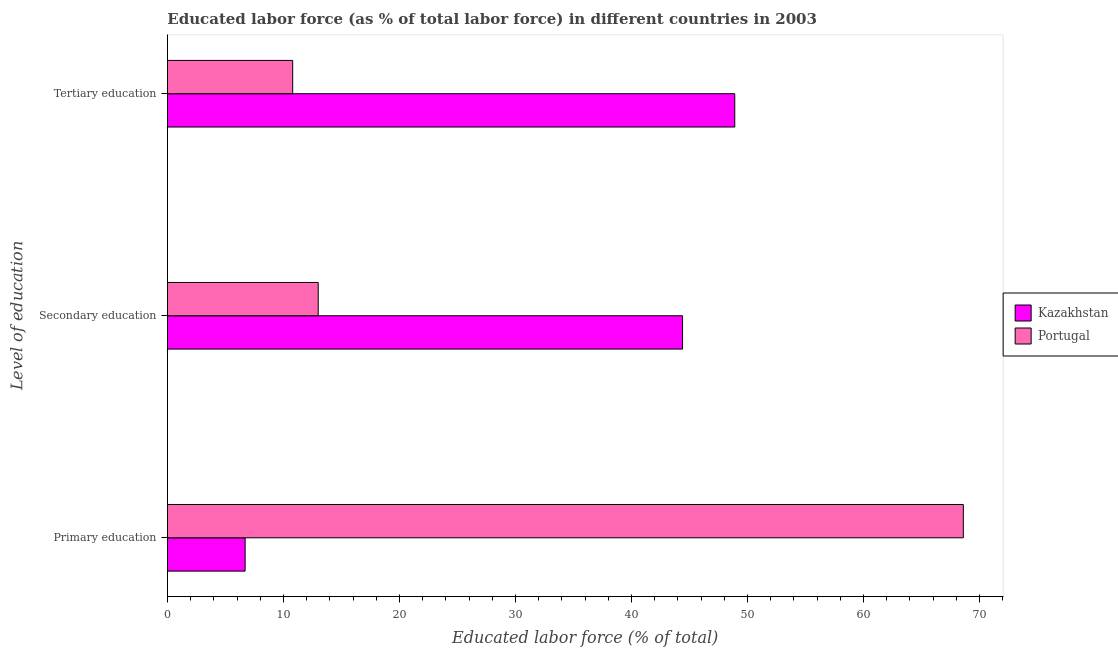How many different coloured bars are there?
Give a very brief answer. 2. How many groups of bars are there?
Provide a short and direct response. 3. Are the number of bars per tick equal to the number of legend labels?
Your answer should be compact. Yes. How many bars are there on the 2nd tick from the bottom?
Ensure brevity in your answer.  2. What is the label of the 1st group of bars from the top?
Provide a succinct answer. Tertiary education. What is the percentage of labor force who received tertiary education in Portugal?
Provide a short and direct response. 10.8. Across all countries, what is the maximum percentage of labor force who received primary education?
Offer a terse response. 68.6. In which country was the percentage of labor force who received secondary education maximum?
Offer a very short reply. Kazakhstan. In which country was the percentage of labor force who received primary education minimum?
Your answer should be compact. Kazakhstan. What is the total percentage of labor force who received secondary education in the graph?
Offer a very short reply. 57.4. What is the difference between the percentage of labor force who received secondary education in Portugal and that in Kazakhstan?
Make the answer very short. -31.4. What is the difference between the percentage of labor force who received tertiary education in Portugal and the percentage of labor force who received primary education in Kazakhstan?
Make the answer very short. 4.1. What is the average percentage of labor force who received primary education per country?
Your answer should be compact. 37.65. What is the difference between the percentage of labor force who received secondary education and percentage of labor force who received primary education in Kazakhstan?
Offer a terse response. 37.7. In how many countries, is the percentage of labor force who received primary education greater than 64 %?
Ensure brevity in your answer.  1. What is the ratio of the percentage of labor force who received tertiary education in Portugal to that in Kazakhstan?
Offer a terse response. 0.22. Is the difference between the percentage of labor force who received secondary education in Portugal and Kazakhstan greater than the difference between the percentage of labor force who received tertiary education in Portugal and Kazakhstan?
Give a very brief answer. Yes. What is the difference between the highest and the second highest percentage of labor force who received primary education?
Give a very brief answer. 61.9. What is the difference between the highest and the lowest percentage of labor force who received tertiary education?
Make the answer very short. 38.1. What does the 1st bar from the top in Primary education represents?
Provide a succinct answer. Portugal. What does the 1st bar from the bottom in Tertiary education represents?
Your answer should be very brief. Kazakhstan. Is it the case that in every country, the sum of the percentage of labor force who received primary education and percentage of labor force who received secondary education is greater than the percentage of labor force who received tertiary education?
Provide a succinct answer. Yes. How many bars are there?
Keep it short and to the point. 6. How many countries are there in the graph?
Provide a short and direct response. 2. Where does the legend appear in the graph?
Your answer should be compact. Center right. How are the legend labels stacked?
Offer a very short reply. Vertical. What is the title of the graph?
Provide a short and direct response. Educated labor force (as % of total labor force) in different countries in 2003. What is the label or title of the X-axis?
Your answer should be very brief. Educated labor force (% of total). What is the label or title of the Y-axis?
Ensure brevity in your answer.  Level of education. What is the Educated labor force (% of total) in Kazakhstan in Primary education?
Your answer should be very brief. 6.7. What is the Educated labor force (% of total) of Portugal in Primary education?
Make the answer very short. 68.6. What is the Educated labor force (% of total) in Kazakhstan in Secondary education?
Give a very brief answer. 44.4. What is the Educated labor force (% of total) in Portugal in Secondary education?
Offer a very short reply. 13. What is the Educated labor force (% of total) of Kazakhstan in Tertiary education?
Give a very brief answer. 48.9. What is the Educated labor force (% of total) of Portugal in Tertiary education?
Offer a terse response. 10.8. Across all Level of education, what is the maximum Educated labor force (% of total) in Kazakhstan?
Your response must be concise. 48.9. Across all Level of education, what is the maximum Educated labor force (% of total) of Portugal?
Your answer should be very brief. 68.6. Across all Level of education, what is the minimum Educated labor force (% of total) of Kazakhstan?
Make the answer very short. 6.7. Across all Level of education, what is the minimum Educated labor force (% of total) in Portugal?
Provide a short and direct response. 10.8. What is the total Educated labor force (% of total) in Kazakhstan in the graph?
Give a very brief answer. 100. What is the total Educated labor force (% of total) in Portugal in the graph?
Give a very brief answer. 92.4. What is the difference between the Educated labor force (% of total) of Kazakhstan in Primary education and that in Secondary education?
Provide a short and direct response. -37.7. What is the difference between the Educated labor force (% of total) of Portugal in Primary education and that in Secondary education?
Offer a terse response. 55.6. What is the difference between the Educated labor force (% of total) in Kazakhstan in Primary education and that in Tertiary education?
Your response must be concise. -42.2. What is the difference between the Educated labor force (% of total) of Portugal in Primary education and that in Tertiary education?
Your response must be concise. 57.8. What is the difference between the Educated labor force (% of total) in Portugal in Secondary education and that in Tertiary education?
Provide a succinct answer. 2.2. What is the difference between the Educated labor force (% of total) of Kazakhstan in Primary education and the Educated labor force (% of total) of Portugal in Secondary education?
Your answer should be compact. -6.3. What is the difference between the Educated labor force (% of total) of Kazakhstan in Primary education and the Educated labor force (% of total) of Portugal in Tertiary education?
Offer a very short reply. -4.1. What is the difference between the Educated labor force (% of total) in Kazakhstan in Secondary education and the Educated labor force (% of total) in Portugal in Tertiary education?
Provide a short and direct response. 33.6. What is the average Educated labor force (% of total) in Kazakhstan per Level of education?
Your answer should be very brief. 33.33. What is the average Educated labor force (% of total) of Portugal per Level of education?
Your answer should be very brief. 30.8. What is the difference between the Educated labor force (% of total) in Kazakhstan and Educated labor force (% of total) in Portugal in Primary education?
Give a very brief answer. -61.9. What is the difference between the Educated labor force (% of total) of Kazakhstan and Educated labor force (% of total) of Portugal in Secondary education?
Your answer should be very brief. 31.4. What is the difference between the Educated labor force (% of total) of Kazakhstan and Educated labor force (% of total) of Portugal in Tertiary education?
Keep it short and to the point. 38.1. What is the ratio of the Educated labor force (% of total) in Kazakhstan in Primary education to that in Secondary education?
Your answer should be very brief. 0.15. What is the ratio of the Educated labor force (% of total) in Portugal in Primary education to that in Secondary education?
Make the answer very short. 5.28. What is the ratio of the Educated labor force (% of total) of Kazakhstan in Primary education to that in Tertiary education?
Make the answer very short. 0.14. What is the ratio of the Educated labor force (% of total) in Portugal in Primary education to that in Tertiary education?
Provide a succinct answer. 6.35. What is the ratio of the Educated labor force (% of total) of Kazakhstan in Secondary education to that in Tertiary education?
Your answer should be compact. 0.91. What is the ratio of the Educated labor force (% of total) of Portugal in Secondary education to that in Tertiary education?
Provide a short and direct response. 1.2. What is the difference between the highest and the second highest Educated labor force (% of total) in Kazakhstan?
Your response must be concise. 4.5. What is the difference between the highest and the second highest Educated labor force (% of total) in Portugal?
Keep it short and to the point. 55.6. What is the difference between the highest and the lowest Educated labor force (% of total) in Kazakhstan?
Offer a very short reply. 42.2. What is the difference between the highest and the lowest Educated labor force (% of total) in Portugal?
Give a very brief answer. 57.8. 